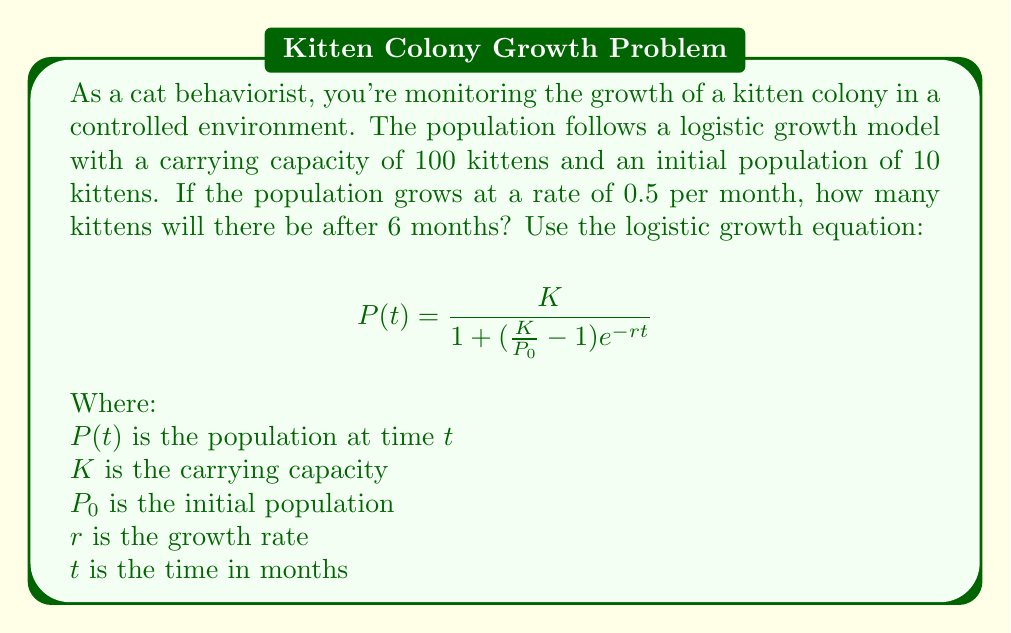Show me your answer to this math problem. Let's solve this step-by-step:

1) We're given:
   $K = 100$ (carrying capacity)
   $P_0 = 10$ (initial population)
   $r = 0.5$ (growth rate per month)
   $t = 6$ (time in months)

2) We'll use the logistic growth equation:
   $$P(t) = \frac{K}{1 + (\frac{K}{P_0} - 1)e^{-rt}}$$

3) Let's substitute our values:
   $$P(6) = \frac{100}{1 + (\frac{100}{10} - 1)e^{-0.5(6)}}$$

4) Simplify inside the parentheses:
   $$P(6) = \frac{100}{1 + (10 - 1)e^{-3}}$$
   $$P(6) = \frac{100}{1 + 9e^{-3}}$$

5) Calculate $e^{-3}$:
   $e^{-3} \approx 0.0498$

6) Substitute this value:
   $$P(6) = \frac{100}{1 + 9(0.0498)}$$
   $$P(6) = \frac{100}{1 + 0.4482}$$
   $$P(6) = \frac{100}{1.4482}$$

7) Calculate the final result:
   $$P(6) \approx 69.05$$

8) Since we're dealing with whole kittens, we round to the nearest integer:
   $$P(6) \approx 69$$

Therefore, after 6 months, there will be approximately 69 kittens in the colony.
Answer: 69 kittens 